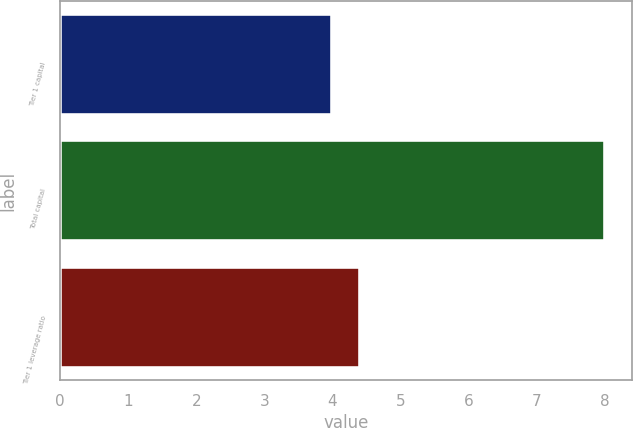Convert chart to OTSL. <chart><loc_0><loc_0><loc_500><loc_500><bar_chart><fcel>Tier 1 capital<fcel>Total capital<fcel>Tier 1 leverage ratio<nl><fcel>4<fcel>8<fcel>4.4<nl></chart> 